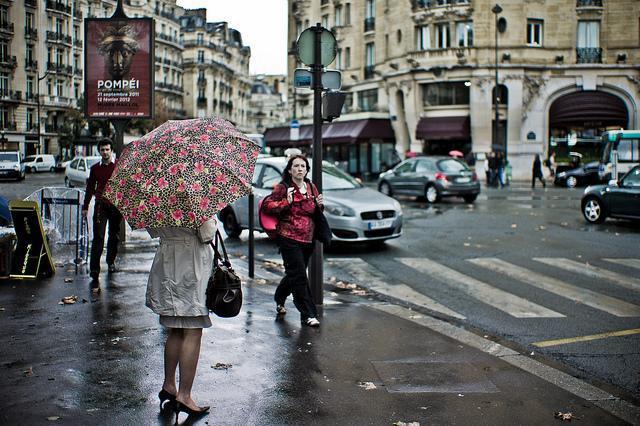How many cars are in the photo?
Give a very brief answer. 3. How many people can be seen?
Give a very brief answer. 3. How many chairs are shown around the table?
Give a very brief answer. 0. 